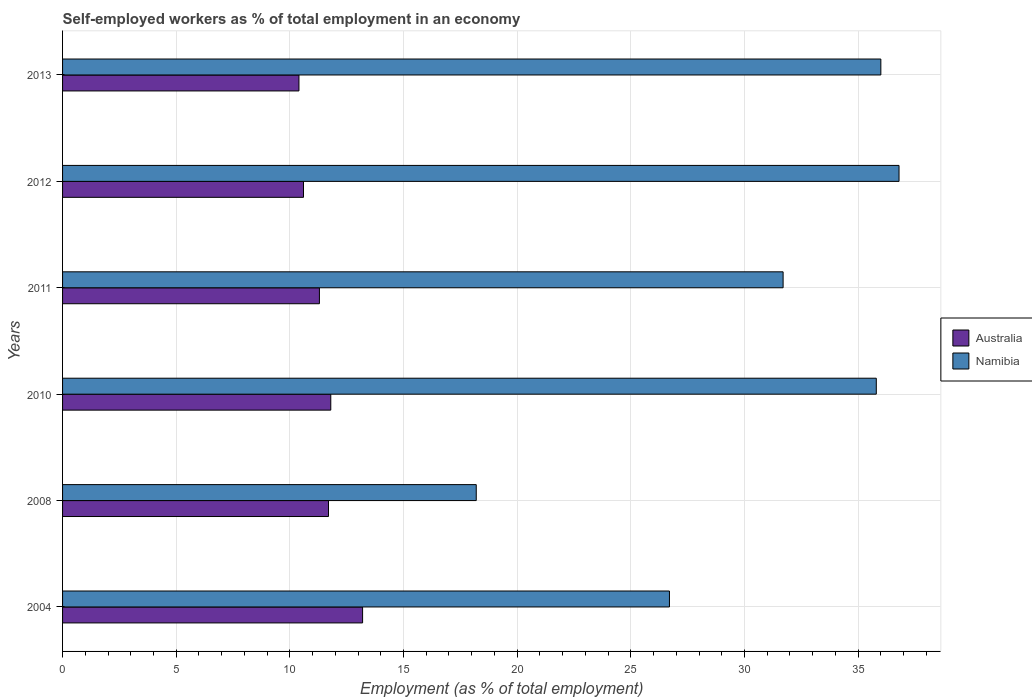Are the number of bars per tick equal to the number of legend labels?
Your answer should be very brief. Yes. How many bars are there on the 6th tick from the top?
Make the answer very short. 2. What is the label of the 5th group of bars from the top?
Give a very brief answer. 2008. What is the percentage of self-employed workers in Australia in 2013?
Your answer should be compact. 10.4. Across all years, what is the maximum percentage of self-employed workers in Namibia?
Your answer should be very brief. 36.8. Across all years, what is the minimum percentage of self-employed workers in Australia?
Give a very brief answer. 10.4. In which year was the percentage of self-employed workers in Namibia maximum?
Your response must be concise. 2012. In which year was the percentage of self-employed workers in Namibia minimum?
Your response must be concise. 2008. What is the total percentage of self-employed workers in Namibia in the graph?
Your response must be concise. 185.2. What is the difference between the percentage of self-employed workers in Namibia in 2004 and that in 2013?
Your response must be concise. -9.3. What is the difference between the percentage of self-employed workers in Namibia in 2010 and the percentage of self-employed workers in Australia in 2013?
Provide a short and direct response. 25.4. What is the average percentage of self-employed workers in Namibia per year?
Offer a very short reply. 30.87. In the year 2010, what is the difference between the percentage of self-employed workers in Australia and percentage of self-employed workers in Namibia?
Make the answer very short. -24. In how many years, is the percentage of self-employed workers in Namibia greater than 37 %?
Your answer should be very brief. 0. What is the ratio of the percentage of self-employed workers in Namibia in 2011 to that in 2012?
Offer a very short reply. 0.86. Is the difference between the percentage of self-employed workers in Australia in 2004 and 2010 greater than the difference between the percentage of self-employed workers in Namibia in 2004 and 2010?
Your answer should be very brief. Yes. What is the difference between the highest and the second highest percentage of self-employed workers in Australia?
Your answer should be very brief. 1.4. What is the difference between the highest and the lowest percentage of self-employed workers in Namibia?
Your answer should be very brief. 18.6. In how many years, is the percentage of self-employed workers in Namibia greater than the average percentage of self-employed workers in Namibia taken over all years?
Provide a succinct answer. 4. Is the sum of the percentage of self-employed workers in Namibia in 2004 and 2012 greater than the maximum percentage of self-employed workers in Australia across all years?
Provide a succinct answer. Yes. What does the 1st bar from the top in 2012 represents?
Make the answer very short. Namibia. How many years are there in the graph?
Your response must be concise. 6. What is the difference between two consecutive major ticks on the X-axis?
Offer a terse response. 5. What is the title of the graph?
Your answer should be compact. Self-employed workers as % of total employment in an economy. What is the label or title of the X-axis?
Keep it short and to the point. Employment (as % of total employment). What is the Employment (as % of total employment) of Australia in 2004?
Keep it short and to the point. 13.2. What is the Employment (as % of total employment) of Namibia in 2004?
Offer a terse response. 26.7. What is the Employment (as % of total employment) in Australia in 2008?
Offer a very short reply. 11.7. What is the Employment (as % of total employment) in Namibia in 2008?
Offer a terse response. 18.2. What is the Employment (as % of total employment) of Australia in 2010?
Keep it short and to the point. 11.8. What is the Employment (as % of total employment) of Namibia in 2010?
Offer a very short reply. 35.8. What is the Employment (as % of total employment) of Australia in 2011?
Your response must be concise. 11.3. What is the Employment (as % of total employment) in Namibia in 2011?
Offer a terse response. 31.7. What is the Employment (as % of total employment) in Australia in 2012?
Your answer should be compact. 10.6. What is the Employment (as % of total employment) of Namibia in 2012?
Keep it short and to the point. 36.8. What is the Employment (as % of total employment) in Australia in 2013?
Your answer should be very brief. 10.4. Across all years, what is the maximum Employment (as % of total employment) of Australia?
Give a very brief answer. 13.2. Across all years, what is the maximum Employment (as % of total employment) in Namibia?
Your answer should be very brief. 36.8. Across all years, what is the minimum Employment (as % of total employment) in Australia?
Ensure brevity in your answer.  10.4. Across all years, what is the minimum Employment (as % of total employment) in Namibia?
Offer a very short reply. 18.2. What is the total Employment (as % of total employment) of Australia in the graph?
Provide a succinct answer. 69. What is the total Employment (as % of total employment) of Namibia in the graph?
Offer a terse response. 185.2. What is the difference between the Employment (as % of total employment) of Namibia in 2004 and that in 2008?
Ensure brevity in your answer.  8.5. What is the difference between the Employment (as % of total employment) in Australia in 2004 and that in 2011?
Your answer should be very brief. 1.9. What is the difference between the Employment (as % of total employment) in Namibia in 2004 and that in 2011?
Your response must be concise. -5. What is the difference between the Employment (as % of total employment) of Namibia in 2004 and that in 2013?
Offer a terse response. -9.3. What is the difference between the Employment (as % of total employment) in Namibia in 2008 and that in 2010?
Provide a short and direct response. -17.6. What is the difference between the Employment (as % of total employment) of Namibia in 2008 and that in 2012?
Make the answer very short. -18.6. What is the difference between the Employment (as % of total employment) of Australia in 2008 and that in 2013?
Offer a terse response. 1.3. What is the difference between the Employment (as % of total employment) in Namibia in 2008 and that in 2013?
Provide a short and direct response. -17.8. What is the difference between the Employment (as % of total employment) in Australia in 2010 and that in 2011?
Offer a terse response. 0.5. What is the difference between the Employment (as % of total employment) of Namibia in 2010 and that in 2011?
Your answer should be compact. 4.1. What is the difference between the Employment (as % of total employment) in Australia in 2010 and that in 2012?
Offer a very short reply. 1.2. What is the difference between the Employment (as % of total employment) in Namibia in 2010 and that in 2012?
Ensure brevity in your answer.  -1. What is the difference between the Employment (as % of total employment) of Australia in 2011 and that in 2012?
Make the answer very short. 0.7. What is the difference between the Employment (as % of total employment) of Australia in 2012 and that in 2013?
Ensure brevity in your answer.  0.2. What is the difference between the Employment (as % of total employment) of Namibia in 2012 and that in 2013?
Make the answer very short. 0.8. What is the difference between the Employment (as % of total employment) in Australia in 2004 and the Employment (as % of total employment) in Namibia in 2010?
Offer a terse response. -22.6. What is the difference between the Employment (as % of total employment) of Australia in 2004 and the Employment (as % of total employment) of Namibia in 2011?
Provide a succinct answer. -18.5. What is the difference between the Employment (as % of total employment) in Australia in 2004 and the Employment (as % of total employment) in Namibia in 2012?
Your response must be concise. -23.6. What is the difference between the Employment (as % of total employment) in Australia in 2004 and the Employment (as % of total employment) in Namibia in 2013?
Offer a terse response. -22.8. What is the difference between the Employment (as % of total employment) of Australia in 2008 and the Employment (as % of total employment) of Namibia in 2010?
Give a very brief answer. -24.1. What is the difference between the Employment (as % of total employment) of Australia in 2008 and the Employment (as % of total employment) of Namibia in 2011?
Give a very brief answer. -20. What is the difference between the Employment (as % of total employment) in Australia in 2008 and the Employment (as % of total employment) in Namibia in 2012?
Your response must be concise. -25.1. What is the difference between the Employment (as % of total employment) of Australia in 2008 and the Employment (as % of total employment) of Namibia in 2013?
Provide a succinct answer. -24.3. What is the difference between the Employment (as % of total employment) of Australia in 2010 and the Employment (as % of total employment) of Namibia in 2011?
Provide a short and direct response. -19.9. What is the difference between the Employment (as % of total employment) of Australia in 2010 and the Employment (as % of total employment) of Namibia in 2013?
Give a very brief answer. -24.2. What is the difference between the Employment (as % of total employment) in Australia in 2011 and the Employment (as % of total employment) in Namibia in 2012?
Provide a short and direct response. -25.5. What is the difference between the Employment (as % of total employment) in Australia in 2011 and the Employment (as % of total employment) in Namibia in 2013?
Keep it short and to the point. -24.7. What is the difference between the Employment (as % of total employment) in Australia in 2012 and the Employment (as % of total employment) in Namibia in 2013?
Offer a terse response. -25.4. What is the average Employment (as % of total employment) in Australia per year?
Offer a terse response. 11.5. What is the average Employment (as % of total employment) of Namibia per year?
Keep it short and to the point. 30.87. In the year 2004, what is the difference between the Employment (as % of total employment) of Australia and Employment (as % of total employment) of Namibia?
Ensure brevity in your answer.  -13.5. In the year 2010, what is the difference between the Employment (as % of total employment) of Australia and Employment (as % of total employment) of Namibia?
Your response must be concise. -24. In the year 2011, what is the difference between the Employment (as % of total employment) in Australia and Employment (as % of total employment) in Namibia?
Give a very brief answer. -20.4. In the year 2012, what is the difference between the Employment (as % of total employment) in Australia and Employment (as % of total employment) in Namibia?
Your answer should be very brief. -26.2. In the year 2013, what is the difference between the Employment (as % of total employment) in Australia and Employment (as % of total employment) in Namibia?
Ensure brevity in your answer.  -25.6. What is the ratio of the Employment (as % of total employment) in Australia in 2004 to that in 2008?
Your response must be concise. 1.13. What is the ratio of the Employment (as % of total employment) of Namibia in 2004 to that in 2008?
Give a very brief answer. 1.47. What is the ratio of the Employment (as % of total employment) of Australia in 2004 to that in 2010?
Offer a terse response. 1.12. What is the ratio of the Employment (as % of total employment) in Namibia in 2004 to that in 2010?
Your answer should be compact. 0.75. What is the ratio of the Employment (as % of total employment) of Australia in 2004 to that in 2011?
Your answer should be compact. 1.17. What is the ratio of the Employment (as % of total employment) in Namibia in 2004 to that in 2011?
Provide a short and direct response. 0.84. What is the ratio of the Employment (as % of total employment) in Australia in 2004 to that in 2012?
Keep it short and to the point. 1.25. What is the ratio of the Employment (as % of total employment) in Namibia in 2004 to that in 2012?
Offer a very short reply. 0.73. What is the ratio of the Employment (as % of total employment) of Australia in 2004 to that in 2013?
Provide a short and direct response. 1.27. What is the ratio of the Employment (as % of total employment) of Namibia in 2004 to that in 2013?
Your answer should be very brief. 0.74. What is the ratio of the Employment (as % of total employment) in Australia in 2008 to that in 2010?
Keep it short and to the point. 0.99. What is the ratio of the Employment (as % of total employment) of Namibia in 2008 to that in 2010?
Make the answer very short. 0.51. What is the ratio of the Employment (as % of total employment) of Australia in 2008 to that in 2011?
Your answer should be very brief. 1.04. What is the ratio of the Employment (as % of total employment) in Namibia in 2008 to that in 2011?
Offer a terse response. 0.57. What is the ratio of the Employment (as % of total employment) of Australia in 2008 to that in 2012?
Provide a short and direct response. 1.1. What is the ratio of the Employment (as % of total employment) in Namibia in 2008 to that in 2012?
Keep it short and to the point. 0.49. What is the ratio of the Employment (as % of total employment) in Australia in 2008 to that in 2013?
Provide a short and direct response. 1.12. What is the ratio of the Employment (as % of total employment) of Namibia in 2008 to that in 2013?
Provide a succinct answer. 0.51. What is the ratio of the Employment (as % of total employment) in Australia in 2010 to that in 2011?
Your answer should be very brief. 1.04. What is the ratio of the Employment (as % of total employment) of Namibia in 2010 to that in 2011?
Provide a succinct answer. 1.13. What is the ratio of the Employment (as % of total employment) of Australia in 2010 to that in 2012?
Provide a short and direct response. 1.11. What is the ratio of the Employment (as % of total employment) of Namibia in 2010 to that in 2012?
Give a very brief answer. 0.97. What is the ratio of the Employment (as % of total employment) of Australia in 2010 to that in 2013?
Your answer should be compact. 1.13. What is the ratio of the Employment (as % of total employment) of Namibia in 2010 to that in 2013?
Make the answer very short. 0.99. What is the ratio of the Employment (as % of total employment) in Australia in 2011 to that in 2012?
Provide a short and direct response. 1.07. What is the ratio of the Employment (as % of total employment) of Namibia in 2011 to that in 2012?
Your answer should be very brief. 0.86. What is the ratio of the Employment (as % of total employment) in Australia in 2011 to that in 2013?
Your answer should be very brief. 1.09. What is the ratio of the Employment (as % of total employment) in Namibia in 2011 to that in 2013?
Keep it short and to the point. 0.88. What is the ratio of the Employment (as % of total employment) in Australia in 2012 to that in 2013?
Your answer should be compact. 1.02. What is the ratio of the Employment (as % of total employment) of Namibia in 2012 to that in 2013?
Give a very brief answer. 1.02. What is the difference between the highest and the lowest Employment (as % of total employment) of Australia?
Your answer should be compact. 2.8. What is the difference between the highest and the lowest Employment (as % of total employment) of Namibia?
Provide a short and direct response. 18.6. 